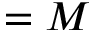<formula> <loc_0><loc_0><loc_500><loc_500>= M</formula> 